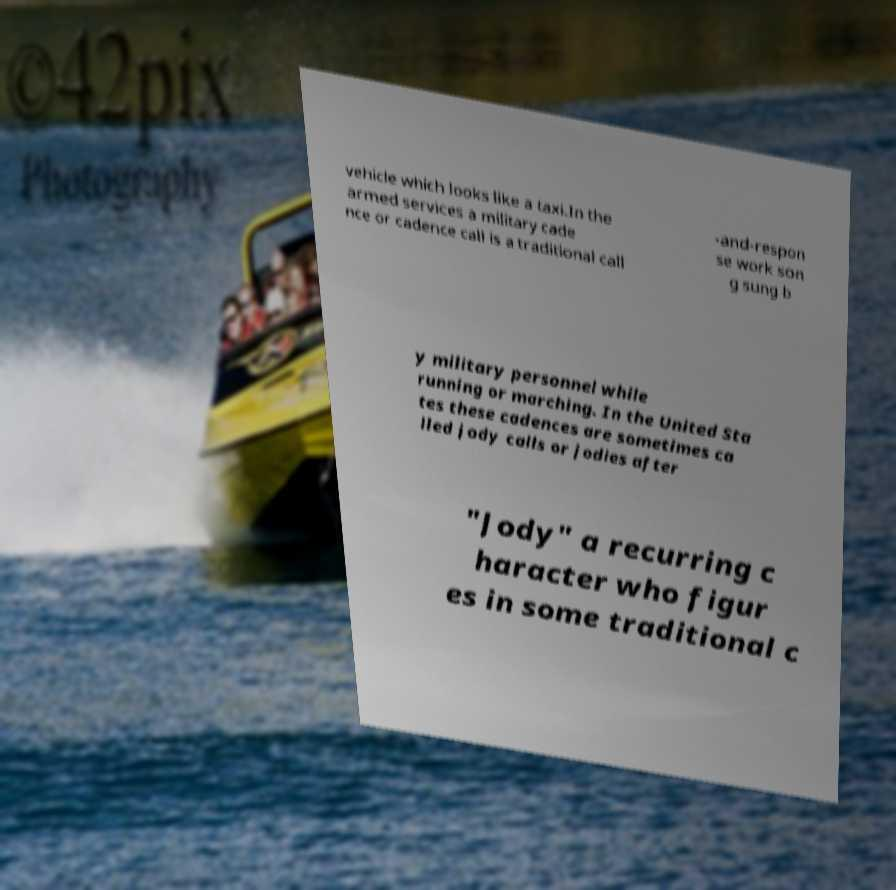There's text embedded in this image that I need extracted. Can you transcribe it verbatim? vehicle which looks like a taxi.In the armed services a military cade nce or cadence call is a traditional call -and-respon se work son g sung b y military personnel while running or marching. In the United Sta tes these cadences are sometimes ca lled jody calls or jodies after "Jody" a recurring c haracter who figur es in some traditional c 